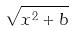Convert formula to latex. <formula><loc_0><loc_0><loc_500><loc_500>\sqrt { x ^ { 2 } + b }</formula> 